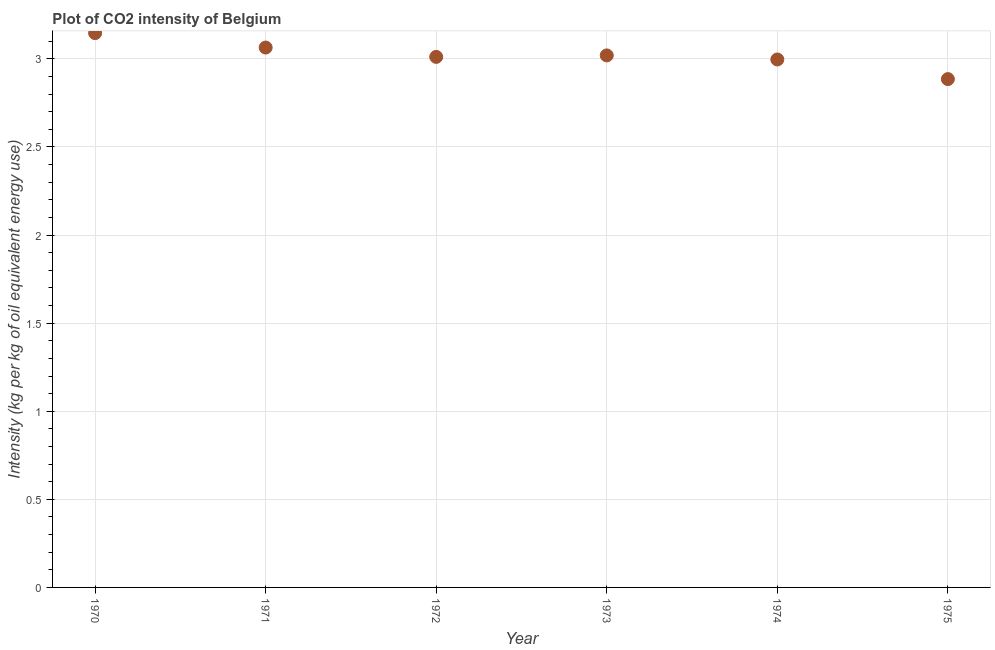What is the co2 intensity in 1975?
Your response must be concise. 2.89. Across all years, what is the maximum co2 intensity?
Provide a short and direct response. 3.15. Across all years, what is the minimum co2 intensity?
Your answer should be compact. 2.89. In which year was the co2 intensity minimum?
Give a very brief answer. 1975. What is the sum of the co2 intensity?
Your answer should be compact. 18.12. What is the difference between the co2 intensity in 1970 and 1972?
Give a very brief answer. 0.13. What is the average co2 intensity per year?
Your answer should be very brief. 3.02. What is the median co2 intensity?
Make the answer very short. 3.02. What is the ratio of the co2 intensity in 1973 to that in 1975?
Make the answer very short. 1.05. Is the co2 intensity in 1971 less than that in 1972?
Your response must be concise. No. What is the difference between the highest and the second highest co2 intensity?
Your answer should be compact. 0.08. What is the difference between the highest and the lowest co2 intensity?
Give a very brief answer. 0.26. Are the values on the major ticks of Y-axis written in scientific E-notation?
Provide a succinct answer. No. What is the title of the graph?
Provide a succinct answer. Plot of CO2 intensity of Belgium. What is the label or title of the X-axis?
Provide a short and direct response. Year. What is the label or title of the Y-axis?
Offer a very short reply. Intensity (kg per kg of oil equivalent energy use). What is the Intensity (kg per kg of oil equivalent energy use) in 1970?
Ensure brevity in your answer.  3.15. What is the Intensity (kg per kg of oil equivalent energy use) in 1971?
Your answer should be compact. 3.06. What is the Intensity (kg per kg of oil equivalent energy use) in 1972?
Offer a terse response. 3.01. What is the Intensity (kg per kg of oil equivalent energy use) in 1973?
Make the answer very short. 3.02. What is the Intensity (kg per kg of oil equivalent energy use) in 1974?
Your answer should be very brief. 3. What is the Intensity (kg per kg of oil equivalent energy use) in 1975?
Provide a succinct answer. 2.89. What is the difference between the Intensity (kg per kg of oil equivalent energy use) in 1970 and 1971?
Ensure brevity in your answer.  0.08. What is the difference between the Intensity (kg per kg of oil equivalent energy use) in 1970 and 1972?
Provide a succinct answer. 0.13. What is the difference between the Intensity (kg per kg of oil equivalent energy use) in 1970 and 1973?
Ensure brevity in your answer.  0.13. What is the difference between the Intensity (kg per kg of oil equivalent energy use) in 1970 and 1974?
Your response must be concise. 0.15. What is the difference between the Intensity (kg per kg of oil equivalent energy use) in 1970 and 1975?
Offer a terse response. 0.26. What is the difference between the Intensity (kg per kg of oil equivalent energy use) in 1971 and 1972?
Provide a succinct answer. 0.05. What is the difference between the Intensity (kg per kg of oil equivalent energy use) in 1971 and 1973?
Ensure brevity in your answer.  0.04. What is the difference between the Intensity (kg per kg of oil equivalent energy use) in 1971 and 1974?
Ensure brevity in your answer.  0.07. What is the difference between the Intensity (kg per kg of oil equivalent energy use) in 1971 and 1975?
Give a very brief answer. 0.18. What is the difference between the Intensity (kg per kg of oil equivalent energy use) in 1972 and 1973?
Your response must be concise. -0.01. What is the difference between the Intensity (kg per kg of oil equivalent energy use) in 1972 and 1974?
Make the answer very short. 0.01. What is the difference between the Intensity (kg per kg of oil equivalent energy use) in 1972 and 1975?
Provide a succinct answer. 0.13. What is the difference between the Intensity (kg per kg of oil equivalent energy use) in 1973 and 1974?
Keep it short and to the point. 0.02. What is the difference between the Intensity (kg per kg of oil equivalent energy use) in 1973 and 1975?
Keep it short and to the point. 0.13. What is the difference between the Intensity (kg per kg of oil equivalent energy use) in 1974 and 1975?
Your answer should be compact. 0.11. What is the ratio of the Intensity (kg per kg of oil equivalent energy use) in 1970 to that in 1972?
Make the answer very short. 1.04. What is the ratio of the Intensity (kg per kg of oil equivalent energy use) in 1970 to that in 1973?
Provide a succinct answer. 1.04. What is the ratio of the Intensity (kg per kg of oil equivalent energy use) in 1970 to that in 1975?
Provide a succinct answer. 1.09. What is the ratio of the Intensity (kg per kg of oil equivalent energy use) in 1971 to that in 1973?
Provide a short and direct response. 1.01. What is the ratio of the Intensity (kg per kg of oil equivalent energy use) in 1971 to that in 1975?
Keep it short and to the point. 1.06. What is the ratio of the Intensity (kg per kg of oil equivalent energy use) in 1972 to that in 1975?
Offer a terse response. 1.04. What is the ratio of the Intensity (kg per kg of oil equivalent energy use) in 1973 to that in 1975?
Your response must be concise. 1.05. What is the ratio of the Intensity (kg per kg of oil equivalent energy use) in 1974 to that in 1975?
Provide a succinct answer. 1.04. 